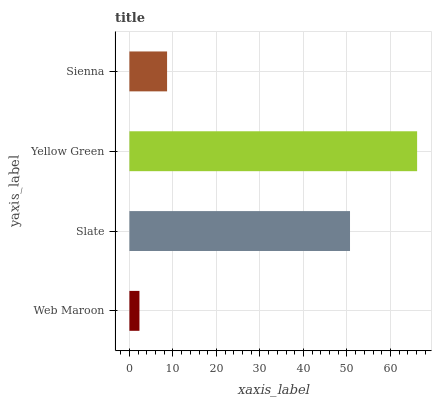Is Web Maroon the minimum?
Answer yes or no. Yes. Is Yellow Green the maximum?
Answer yes or no. Yes. Is Slate the minimum?
Answer yes or no. No. Is Slate the maximum?
Answer yes or no. No. Is Slate greater than Web Maroon?
Answer yes or no. Yes. Is Web Maroon less than Slate?
Answer yes or no. Yes. Is Web Maroon greater than Slate?
Answer yes or no. No. Is Slate less than Web Maroon?
Answer yes or no. No. Is Slate the high median?
Answer yes or no. Yes. Is Sienna the low median?
Answer yes or no. Yes. Is Sienna the high median?
Answer yes or no. No. Is Web Maroon the low median?
Answer yes or no. No. 